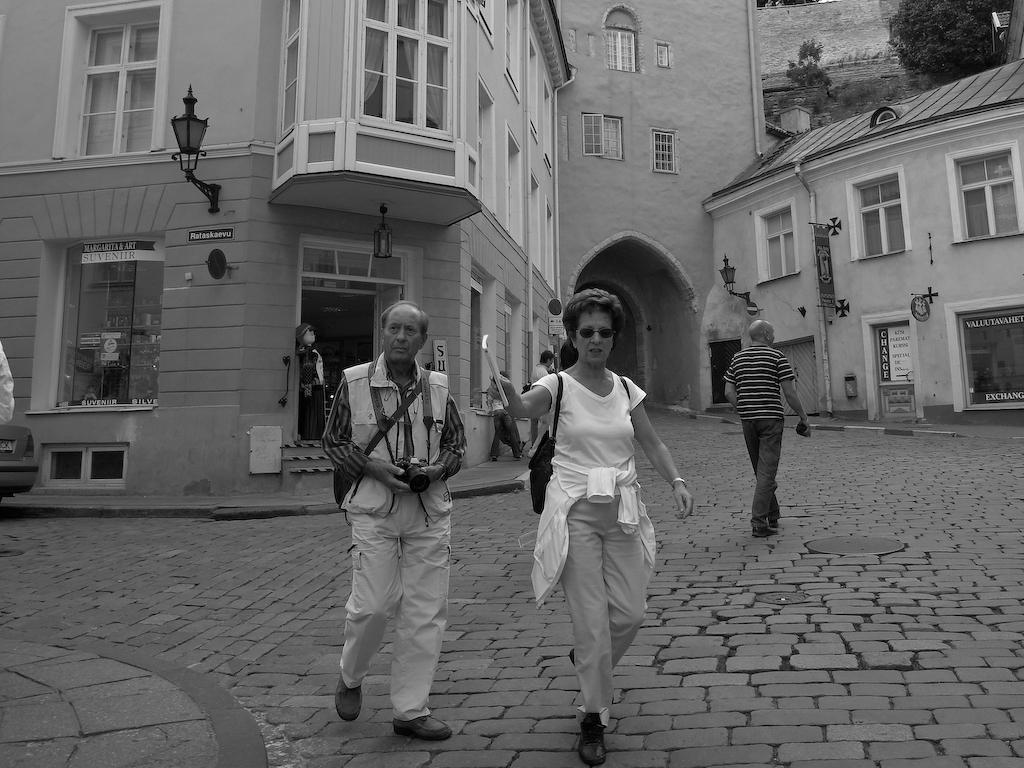How would you summarize this image in a sentence or two? In this picture we can see some people on the ground, lamps, posters, trees, some objects and in the background we can see buildings with windows. 